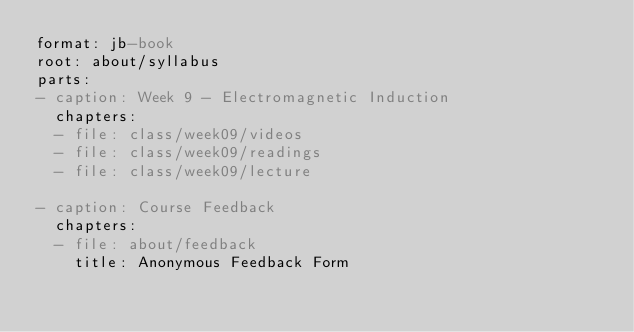<code> <loc_0><loc_0><loc_500><loc_500><_YAML_>format: jb-book
root: about/syllabus
parts:
- caption: Week 9 - Electromagnetic Induction
  chapters:
  - file: class/week09/videos
  - file: class/week09/readings
  - file: class/week09/lecture

- caption: Course Feedback
  chapters:
  - file: about/feedback
    title: Anonymous Feedback Form
</code> 